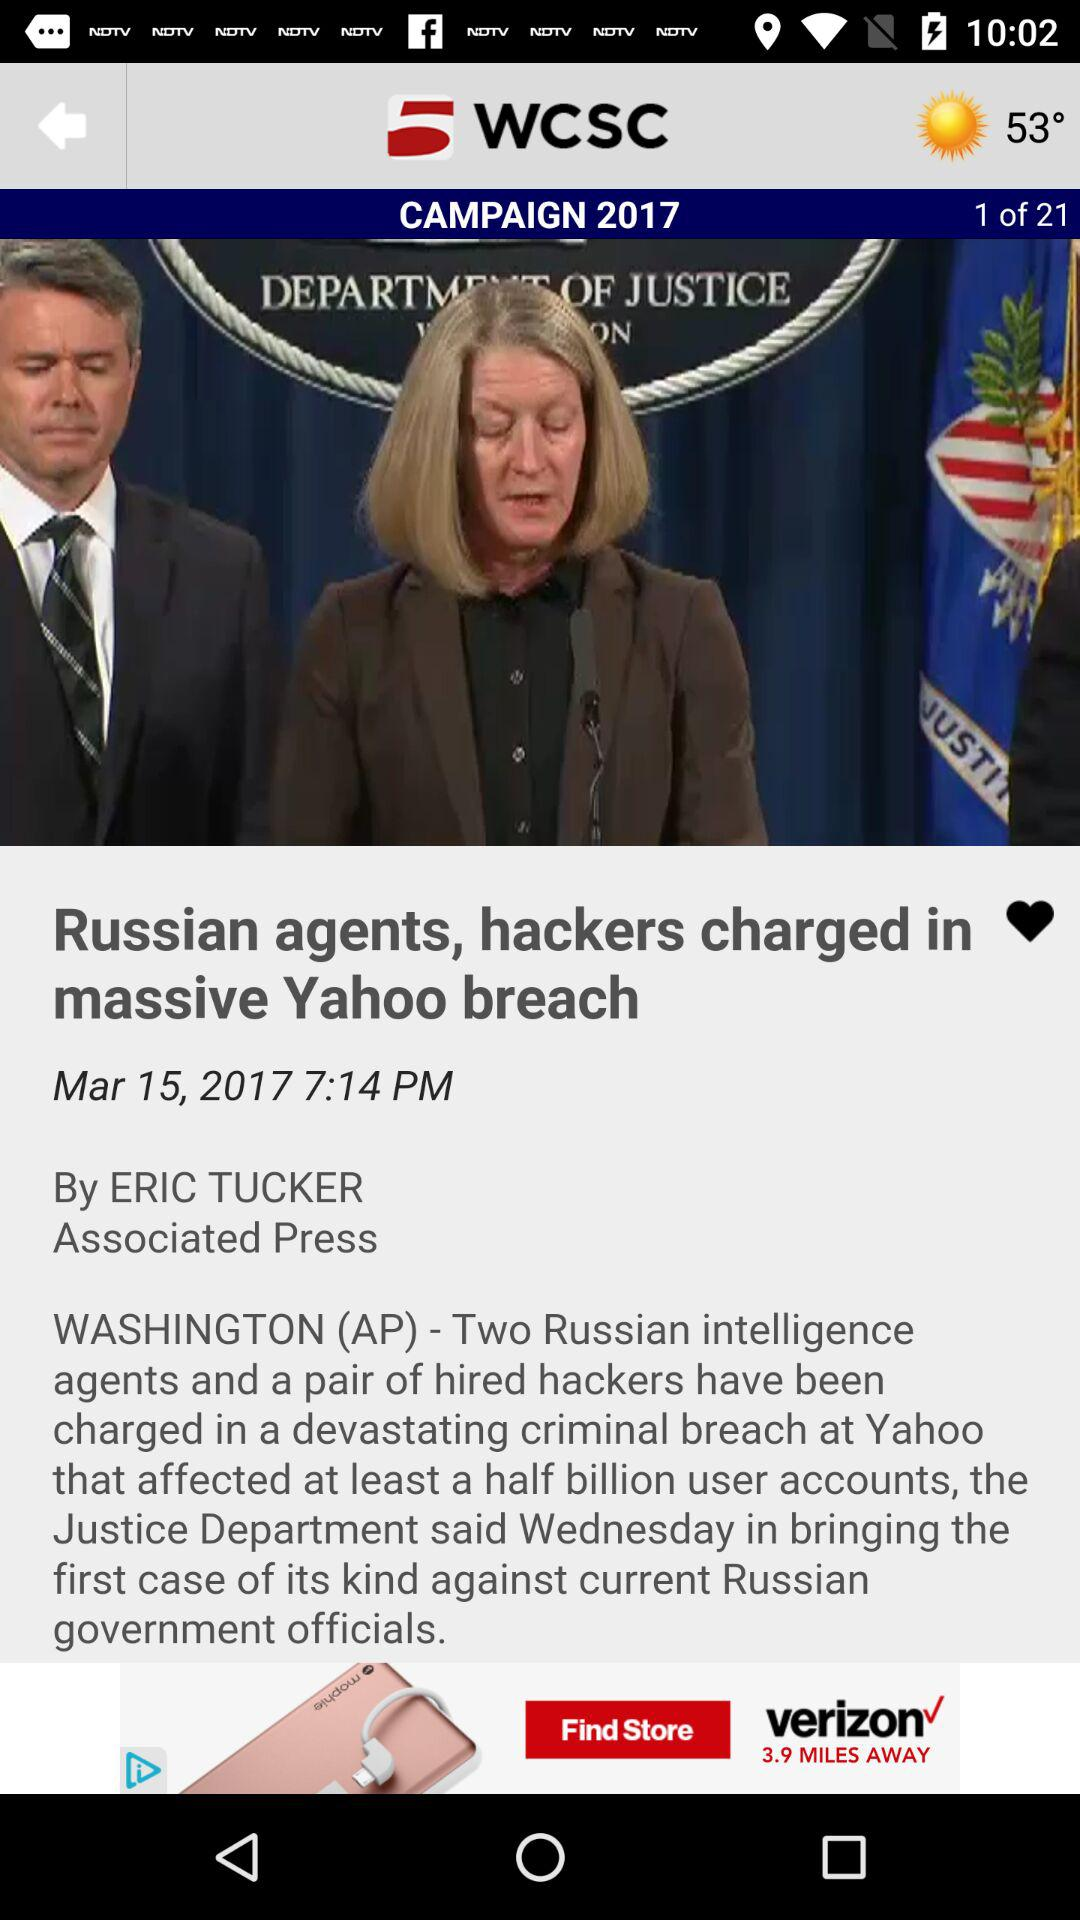What is the name of the application? The name of the application is "5 WCSC". 